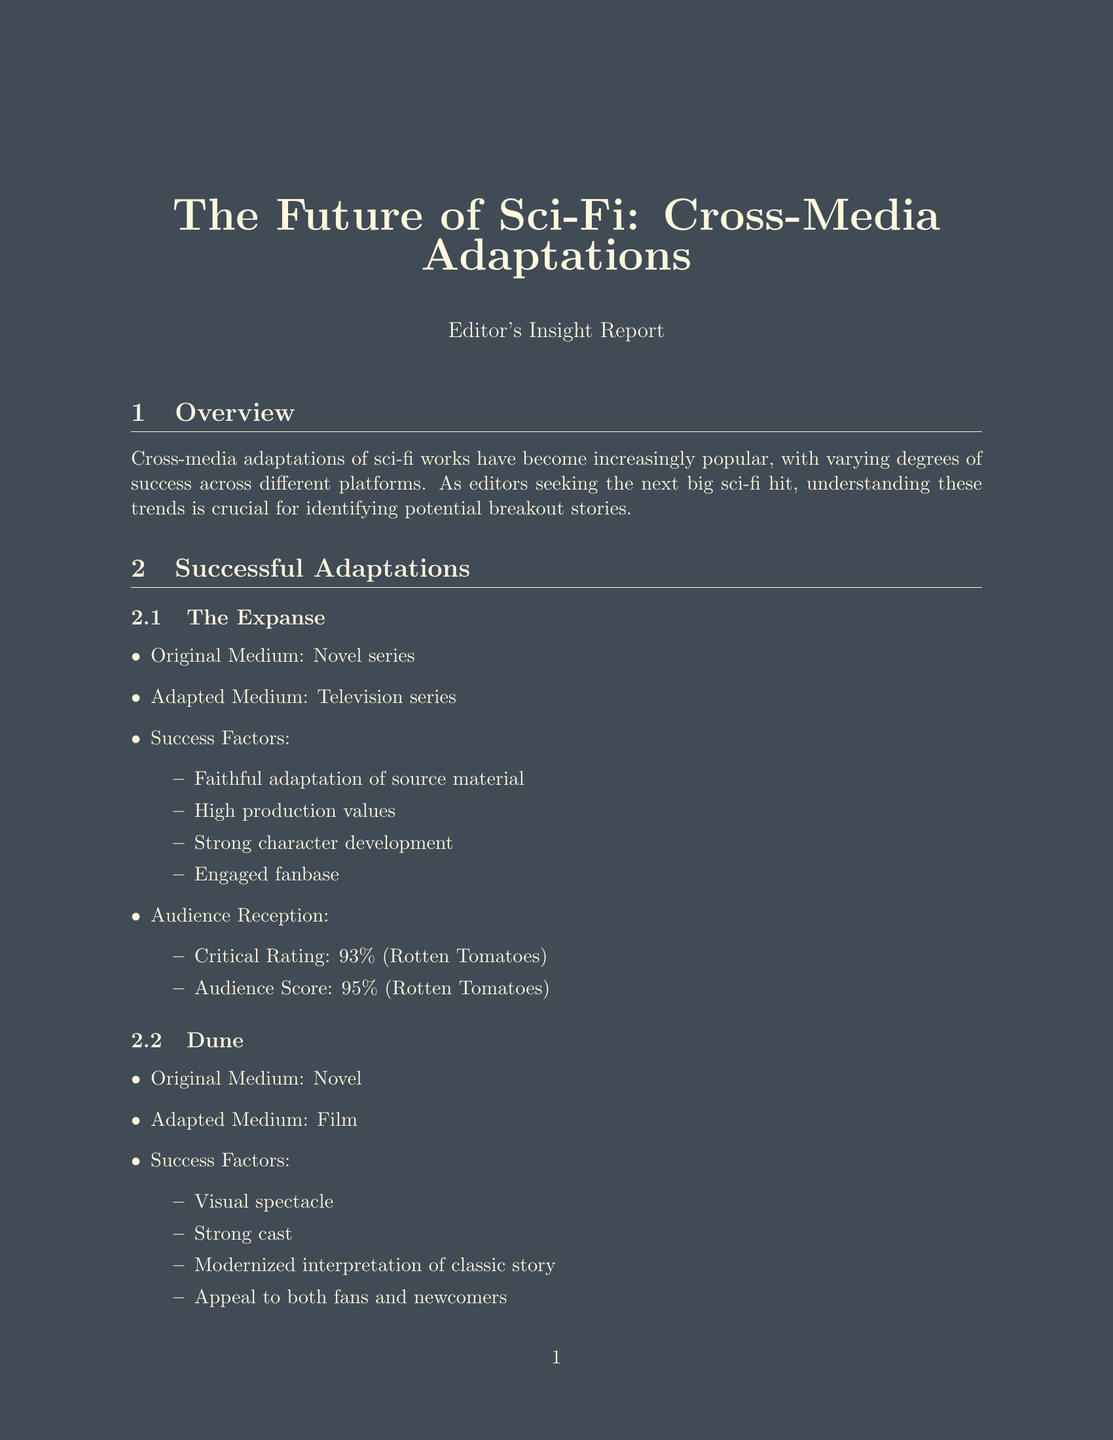What is the success rate for film adaptations? The success rate for film adaptations is mentioned in the adaptation success rates section of the document.
Answer: 62% What is the highest critical rating for a successful adaptation? The critical rating for "The Expanse" is the highest critical rating listed in the successful adaptations section.
Answer: 93% What are the top themes that audiences prefer in sci-fi? The document lists the top themes in the audience preferences section, which includes five specific themes.
Answer: Post-apocalyptic worlds, Space exploration, Artificial intelligence, Time travel, Alternate realities What are the notable failures for video game adaptations? The notable failure for video game adaptations is indicated in the adaptation success rates section.
Answer: Cyberpunk 2077 (at launch) What is the anticipated reception for the adaptation of Hyperion? The anticipated reception for Hyperion is mentioned in the future prospects section of the document.
Answer: High due to complex narrative and devoted fanbase What adaptation had a box office of $401.8 million? The box office revenue is specifically reported for the film adaptation of "Dune" in the audience reception subsection.
Answer: Dune What is a trend identified for future sci-fi adaptations? The emerging trends section of the document provides examples of trends relevant to sci-fi adaptations.
Answer: Interactive storytelling How many successful adaptations are listed in the document? Counting the number of adaptations listed in the successful adaptations section provides the total number.
Answer: 2 